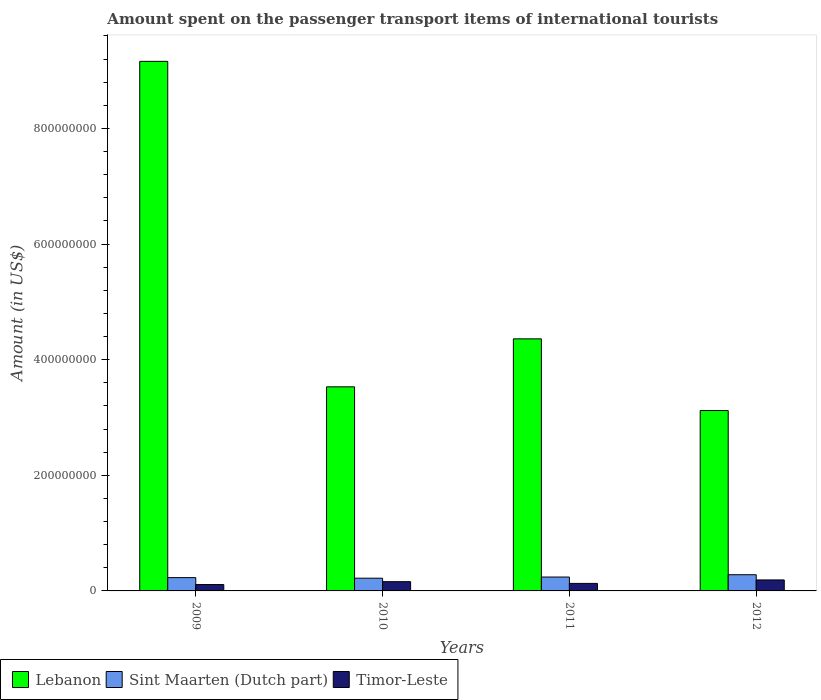Are the number of bars on each tick of the X-axis equal?
Offer a terse response. Yes. What is the label of the 3rd group of bars from the left?
Ensure brevity in your answer.  2011. In how many cases, is the number of bars for a given year not equal to the number of legend labels?
Make the answer very short. 0. What is the amount spent on the passenger transport items of international tourists in Sint Maarten (Dutch part) in 2009?
Your response must be concise. 2.30e+07. Across all years, what is the maximum amount spent on the passenger transport items of international tourists in Timor-Leste?
Give a very brief answer. 1.90e+07. Across all years, what is the minimum amount spent on the passenger transport items of international tourists in Timor-Leste?
Ensure brevity in your answer.  1.10e+07. In which year was the amount spent on the passenger transport items of international tourists in Sint Maarten (Dutch part) maximum?
Provide a short and direct response. 2012. In which year was the amount spent on the passenger transport items of international tourists in Timor-Leste minimum?
Your response must be concise. 2009. What is the total amount spent on the passenger transport items of international tourists in Lebanon in the graph?
Make the answer very short. 2.02e+09. What is the difference between the amount spent on the passenger transport items of international tourists in Timor-Leste in 2011 and the amount spent on the passenger transport items of international tourists in Sint Maarten (Dutch part) in 2012?
Your response must be concise. -1.50e+07. What is the average amount spent on the passenger transport items of international tourists in Timor-Leste per year?
Provide a short and direct response. 1.48e+07. In the year 2012, what is the difference between the amount spent on the passenger transport items of international tourists in Timor-Leste and amount spent on the passenger transport items of international tourists in Sint Maarten (Dutch part)?
Provide a succinct answer. -9.00e+06. What is the ratio of the amount spent on the passenger transport items of international tourists in Sint Maarten (Dutch part) in 2009 to that in 2012?
Give a very brief answer. 0.82. What is the difference between the highest and the second highest amount spent on the passenger transport items of international tourists in Sint Maarten (Dutch part)?
Offer a very short reply. 4.00e+06. What is the difference between the highest and the lowest amount spent on the passenger transport items of international tourists in Lebanon?
Your answer should be compact. 6.04e+08. Is the sum of the amount spent on the passenger transport items of international tourists in Lebanon in 2009 and 2011 greater than the maximum amount spent on the passenger transport items of international tourists in Sint Maarten (Dutch part) across all years?
Provide a short and direct response. Yes. What does the 1st bar from the left in 2010 represents?
Offer a terse response. Lebanon. What does the 3rd bar from the right in 2009 represents?
Make the answer very short. Lebanon. Are all the bars in the graph horizontal?
Make the answer very short. No. What is the difference between two consecutive major ticks on the Y-axis?
Make the answer very short. 2.00e+08. Does the graph contain any zero values?
Provide a short and direct response. No. How are the legend labels stacked?
Your answer should be very brief. Horizontal. What is the title of the graph?
Offer a very short reply. Amount spent on the passenger transport items of international tourists. Does "Ethiopia" appear as one of the legend labels in the graph?
Offer a terse response. No. What is the label or title of the X-axis?
Make the answer very short. Years. What is the Amount (in US$) of Lebanon in 2009?
Ensure brevity in your answer.  9.16e+08. What is the Amount (in US$) in Sint Maarten (Dutch part) in 2009?
Your answer should be compact. 2.30e+07. What is the Amount (in US$) in Timor-Leste in 2009?
Give a very brief answer. 1.10e+07. What is the Amount (in US$) of Lebanon in 2010?
Give a very brief answer. 3.53e+08. What is the Amount (in US$) of Sint Maarten (Dutch part) in 2010?
Give a very brief answer. 2.20e+07. What is the Amount (in US$) of Timor-Leste in 2010?
Keep it short and to the point. 1.60e+07. What is the Amount (in US$) in Lebanon in 2011?
Provide a succinct answer. 4.36e+08. What is the Amount (in US$) in Sint Maarten (Dutch part) in 2011?
Your answer should be very brief. 2.40e+07. What is the Amount (in US$) in Timor-Leste in 2011?
Offer a very short reply. 1.30e+07. What is the Amount (in US$) of Lebanon in 2012?
Ensure brevity in your answer.  3.12e+08. What is the Amount (in US$) of Sint Maarten (Dutch part) in 2012?
Make the answer very short. 2.80e+07. What is the Amount (in US$) in Timor-Leste in 2012?
Your answer should be very brief. 1.90e+07. Across all years, what is the maximum Amount (in US$) in Lebanon?
Make the answer very short. 9.16e+08. Across all years, what is the maximum Amount (in US$) in Sint Maarten (Dutch part)?
Make the answer very short. 2.80e+07. Across all years, what is the maximum Amount (in US$) of Timor-Leste?
Offer a terse response. 1.90e+07. Across all years, what is the minimum Amount (in US$) in Lebanon?
Give a very brief answer. 3.12e+08. Across all years, what is the minimum Amount (in US$) of Sint Maarten (Dutch part)?
Offer a very short reply. 2.20e+07. Across all years, what is the minimum Amount (in US$) in Timor-Leste?
Your answer should be compact. 1.10e+07. What is the total Amount (in US$) of Lebanon in the graph?
Offer a very short reply. 2.02e+09. What is the total Amount (in US$) in Sint Maarten (Dutch part) in the graph?
Give a very brief answer. 9.70e+07. What is the total Amount (in US$) of Timor-Leste in the graph?
Ensure brevity in your answer.  5.90e+07. What is the difference between the Amount (in US$) in Lebanon in 2009 and that in 2010?
Give a very brief answer. 5.63e+08. What is the difference between the Amount (in US$) in Timor-Leste in 2009 and that in 2010?
Ensure brevity in your answer.  -5.00e+06. What is the difference between the Amount (in US$) in Lebanon in 2009 and that in 2011?
Provide a succinct answer. 4.80e+08. What is the difference between the Amount (in US$) of Lebanon in 2009 and that in 2012?
Keep it short and to the point. 6.04e+08. What is the difference between the Amount (in US$) in Sint Maarten (Dutch part) in 2009 and that in 2012?
Your answer should be very brief. -5.00e+06. What is the difference between the Amount (in US$) of Timor-Leste in 2009 and that in 2012?
Offer a terse response. -8.00e+06. What is the difference between the Amount (in US$) of Lebanon in 2010 and that in 2011?
Your answer should be very brief. -8.30e+07. What is the difference between the Amount (in US$) of Sint Maarten (Dutch part) in 2010 and that in 2011?
Offer a terse response. -2.00e+06. What is the difference between the Amount (in US$) of Timor-Leste in 2010 and that in 2011?
Make the answer very short. 3.00e+06. What is the difference between the Amount (in US$) of Lebanon in 2010 and that in 2012?
Your answer should be compact. 4.10e+07. What is the difference between the Amount (in US$) of Sint Maarten (Dutch part) in 2010 and that in 2012?
Your response must be concise. -6.00e+06. What is the difference between the Amount (in US$) of Lebanon in 2011 and that in 2012?
Provide a succinct answer. 1.24e+08. What is the difference between the Amount (in US$) in Timor-Leste in 2011 and that in 2012?
Give a very brief answer. -6.00e+06. What is the difference between the Amount (in US$) of Lebanon in 2009 and the Amount (in US$) of Sint Maarten (Dutch part) in 2010?
Keep it short and to the point. 8.94e+08. What is the difference between the Amount (in US$) in Lebanon in 2009 and the Amount (in US$) in Timor-Leste in 2010?
Your answer should be very brief. 9.00e+08. What is the difference between the Amount (in US$) in Sint Maarten (Dutch part) in 2009 and the Amount (in US$) in Timor-Leste in 2010?
Your answer should be very brief. 7.00e+06. What is the difference between the Amount (in US$) in Lebanon in 2009 and the Amount (in US$) in Sint Maarten (Dutch part) in 2011?
Offer a very short reply. 8.92e+08. What is the difference between the Amount (in US$) in Lebanon in 2009 and the Amount (in US$) in Timor-Leste in 2011?
Make the answer very short. 9.03e+08. What is the difference between the Amount (in US$) of Sint Maarten (Dutch part) in 2009 and the Amount (in US$) of Timor-Leste in 2011?
Keep it short and to the point. 1.00e+07. What is the difference between the Amount (in US$) of Lebanon in 2009 and the Amount (in US$) of Sint Maarten (Dutch part) in 2012?
Offer a terse response. 8.88e+08. What is the difference between the Amount (in US$) of Lebanon in 2009 and the Amount (in US$) of Timor-Leste in 2012?
Your response must be concise. 8.97e+08. What is the difference between the Amount (in US$) in Sint Maarten (Dutch part) in 2009 and the Amount (in US$) in Timor-Leste in 2012?
Provide a succinct answer. 4.00e+06. What is the difference between the Amount (in US$) of Lebanon in 2010 and the Amount (in US$) of Sint Maarten (Dutch part) in 2011?
Provide a succinct answer. 3.29e+08. What is the difference between the Amount (in US$) of Lebanon in 2010 and the Amount (in US$) of Timor-Leste in 2011?
Your answer should be compact. 3.40e+08. What is the difference between the Amount (in US$) in Sint Maarten (Dutch part) in 2010 and the Amount (in US$) in Timor-Leste in 2011?
Your response must be concise. 9.00e+06. What is the difference between the Amount (in US$) in Lebanon in 2010 and the Amount (in US$) in Sint Maarten (Dutch part) in 2012?
Offer a terse response. 3.25e+08. What is the difference between the Amount (in US$) in Lebanon in 2010 and the Amount (in US$) in Timor-Leste in 2012?
Give a very brief answer. 3.34e+08. What is the difference between the Amount (in US$) of Sint Maarten (Dutch part) in 2010 and the Amount (in US$) of Timor-Leste in 2012?
Ensure brevity in your answer.  3.00e+06. What is the difference between the Amount (in US$) in Lebanon in 2011 and the Amount (in US$) in Sint Maarten (Dutch part) in 2012?
Your response must be concise. 4.08e+08. What is the difference between the Amount (in US$) of Lebanon in 2011 and the Amount (in US$) of Timor-Leste in 2012?
Provide a succinct answer. 4.17e+08. What is the difference between the Amount (in US$) in Sint Maarten (Dutch part) in 2011 and the Amount (in US$) in Timor-Leste in 2012?
Ensure brevity in your answer.  5.00e+06. What is the average Amount (in US$) of Lebanon per year?
Keep it short and to the point. 5.04e+08. What is the average Amount (in US$) in Sint Maarten (Dutch part) per year?
Your response must be concise. 2.42e+07. What is the average Amount (in US$) of Timor-Leste per year?
Ensure brevity in your answer.  1.48e+07. In the year 2009, what is the difference between the Amount (in US$) of Lebanon and Amount (in US$) of Sint Maarten (Dutch part)?
Ensure brevity in your answer.  8.93e+08. In the year 2009, what is the difference between the Amount (in US$) in Lebanon and Amount (in US$) in Timor-Leste?
Keep it short and to the point. 9.05e+08. In the year 2010, what is the difference between the Amount (in US$) of Lebanon and Amount (in US$) of Sint Maarten (Dutch part)?
Keep it short and to the point. 3.31e+08. In the year 2010, what is the difference between the Amount (in US$) in Lebanon and Amount (in US$) in Timor-Leste?
Offer a very short reply. 3.37e+08. In the year 2010, what is the difference between the Amount (in US$) in Sint Maarten (Dutch part) and Amount (in US$) in Timor-Leste?
Your answer should be compact. 6.00e+06. In the year 2011, what is the difference between the Amount (in US$) of Lebanon and Amount (in US$) of Sint Maarten (Dutch part)?
Provide a succinct answer. 4.12e+08. In the year 2011, what is the difference between the Amount (in US$) of Lebanon and Amount (in US$) of Timor-Leste?
Your answer should be compact. 4.23e+08. In the year 2011, what is the difference between the Amount (in US$) of Sint Maarten (Dutch part) and Amount (in US$) of Timor-Leste?
Give a very brief answer. 1.10e+07. In the year 2012, what is the difference between the Amount (in US$) of Lebanon and Amount (in US$) of Sint Maarten (Dutch part)?
Your response must be concise. 2.84e+08. In the year 2012, what is the difference between the Amount (in US$) of Lebanon and Amount (in US$) of Timor-Leste?
Ensure brevity in your answer.  2.93e+08. In the year 2012, what is the difference between the Amount (in US$) of Sint Maarten (Dutch part) and Amount (in US$) of Timor-Leste?
Keep it short and to the point. 9.00e+06. What is the ratio of the Amount (in US$) in Lebanon in 2009 to that in 2010?
Provide a succinct answer. 2.59. What is the ratio of the Amount (in US$) in Sint Maarten (Dutch part) in 2009 to that in 2010?
Keep it short and to the point. 1.05. What is the ratio of the Amount (in US$) of Timor-Leste in 2009 to that in 2010?
Make the answer very short. 0.69. What is the ratio of the Amount (in US$) in Lebanon in 2009 to that in 2011?
Ensure brevity in your answer.  2.1. What is the ratio of the Amount (in US$) in Timor-Leste in 2009 to that in 2011?
Offer a very short reply. 0.85. What is the ratio of the Amount (in US$) of Lebanon in 2009 to that in 2012?
Your answer should be compact. 2.94. What is the ratio of the Amount (in US$) of Sint Maarten (Dutch part) in 2009 to that in 2012?
Offer a very short reply. 0.82. What is the ratio of the Amount (in US$) of Timor-Leste in 2009 to that in 2012?
Your answer should be very brief. 0.58. What is the ratio of the Amount (in US$) in Lebanon in 2010 to that in 2011?
Give a very brief answer. 0.81. What is the ratio of the Amount (in US$) of Sint Maarten (Dutch part) in 2010 to that in 2011?
Keep it short and to the point. 0.92. What is the ratio of the Amount (in US$) of Timor-Leste in 2010 to that in 2011?
Offer a terse response. 1.23. What is the ratio of the Amount (in US$) in Lebanon in 2010 to that in 2012?
Your answer should be very brief. 1.13. What is the ratio of the Amount (in US$) of Sint Maarten (Dutch part) in 2010 to that in 2012?
Ensure brevity in your answer.  0.79. What is the ratio of the Amount (in US$) in Timor-Leste in 2010 to that in 2012?
Provide a succinct answer. 0.84. What is the ratio of the Amount (in US$) of Lebanon in 2011 to that in 2012?
Ensure brevity in your answer.  1.4. What is the ratio of the Amount (in US$) of Timor-Leste in 2011 to that in 2012?
Offer a terse response. 0.68. What is the difference between the highest and the second highest Amount (in US$) in Lebanon?
Your response must be concise. 4.80e+08. What is the difference between the highest and the second highest Amount (in US$) in Sint Maarten (Dutch part)?
Your answer should be very brief. 4.00e+06. What is the difference between the highest and the second highest Amount (in US$) in Timor-Leste?
Give a very brief answer. 3.00e+06. What is the difference between the highest and the lowest Amount (in US$) in Lebanon?
Provide a short and direct response. 6.04e+08. What is the difference between the highest and the lowest Amount (in US$) in Sint Maarten (Dutch part)?
Offer a very short reply. 6.00e+06. 